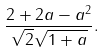Convert formula to latex. <formula><loc_0><loc_0><loc_500><loc_500>\frac { 2 + 2 a - a ^ { 2 } } { \sqrt { 2 } \sqrt { 1 + a } } .</formula> 